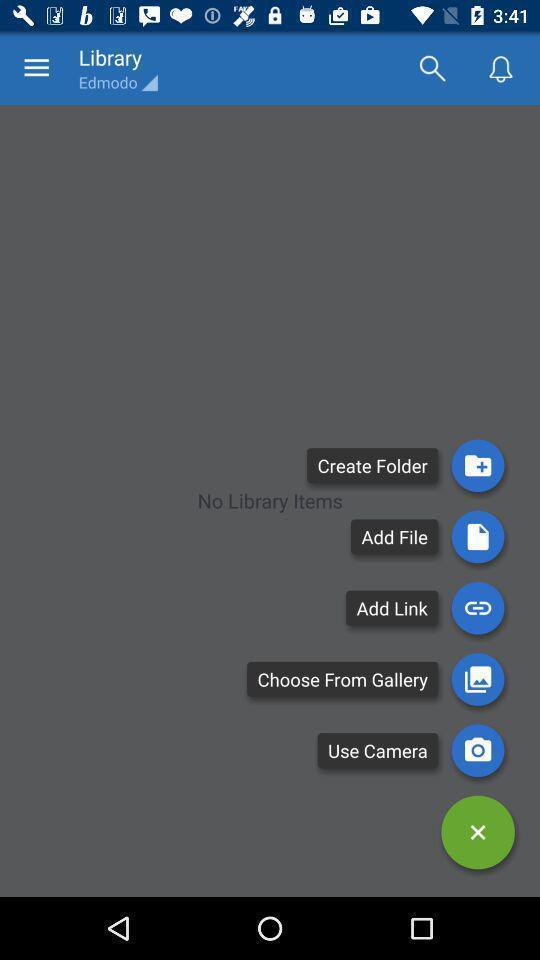Provide a description of this screenshot. Screen display library page of a study app. 